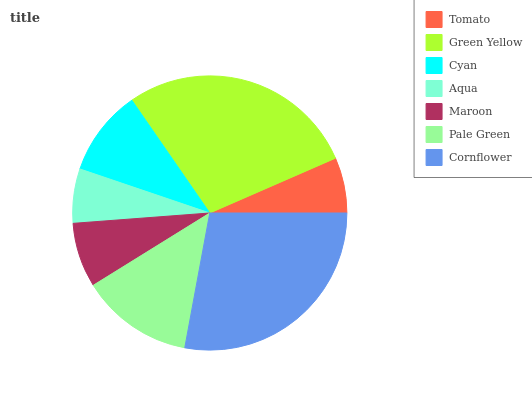Is Aqua the minimum?
Answer yes or no. Yes. Is Green Yellow the maximum?
Answer yes or no. Yes. Is Cyan the minimum?
Answer yes or no. No. Is Cyan the maximum?
Answer yes or no. No. Is Green Yellow greater than Cyan?
Answer yes or no. Yes. Is Cyan less than Green Yellow?
Answer yes or no. Yes. Is Cyan greater than Green Yellow?
Answer yes or no. No. Is Green Yellow less than Cyan?
Answer yes or no. No. Is Cyan the high median?
Answer yes or no. Yes. Is Cyan the low median?
Answer yes or no. Yes. Is Green Yellow the high median?
Answer yes or no. No. Is Tomato the low median?
Answer yes or no. No. 